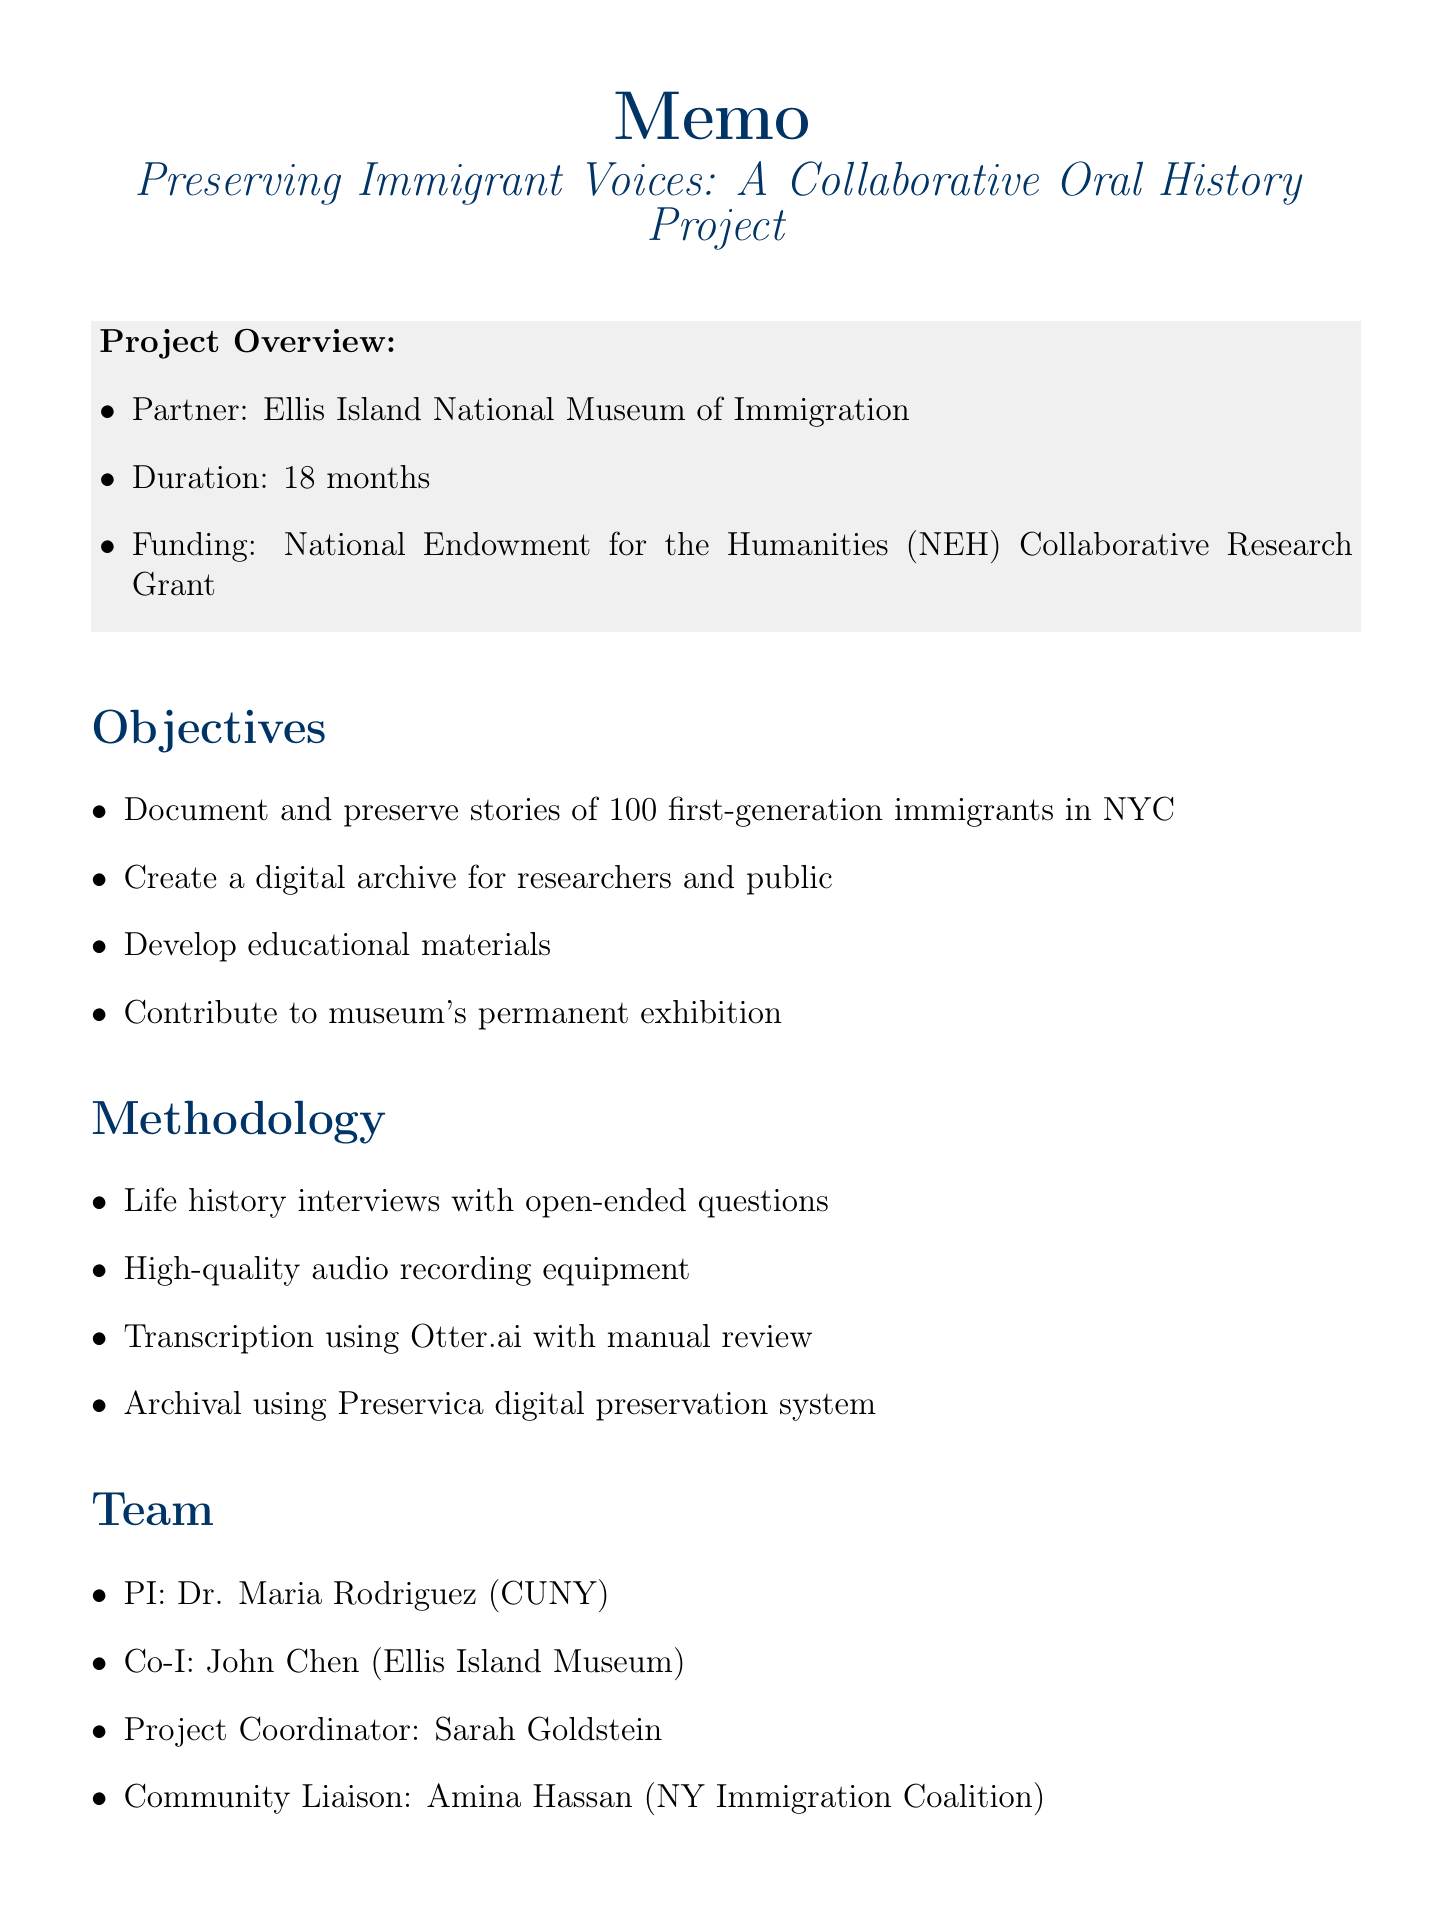what is the title of the project? The title of the project is stated at the start of the document and is "Preserving Immigrant Voices: A Collaborative Oral History Project."
Answer: Preserving Immigrant Voices: A Collaborative Oral History Project who is the principal investigator? The document lists Dr. Maria Rodriguez as the Principal Investigator under the team composition section.
Answer: Dr. Maria Rodriguez how long is the project duration? The duration of the project is mentioned in the project overview as 18 months.
Answer: 18 months what is the total funding requested? The total requested funding is highlighted in the budget section of the document as $275,000.
Answer: $275,000 which museum is partnering with the project? The partner museum mentioned in the project overview is the Ellis Island National Museum of Immigration.
Answer: Ellis Island National Museum of Immigration what ethical consideration allows narrators to review their interviews? The document specifies an "Option for narrators to review and redact sensitive information" as an ethical consideration.
Answer: Option for narrators to review and redact sensitive information how many interviews are planned to be conducted? The number of oral history interviews to be conducted is stated as 100 in the project objectives section.
Answer: 100 what type of interviews will be conducted? The document specifies that life history interviews using open-ended questions will be conducted.
Answer: Life history interviews using open-ended questions what is one of the sources for best practices listed in the document? The document references the Oral History Association's "Principles and Best Practices" as a resource for best practices.
Answer: Oral History Association's "Principles and Best Practices" 